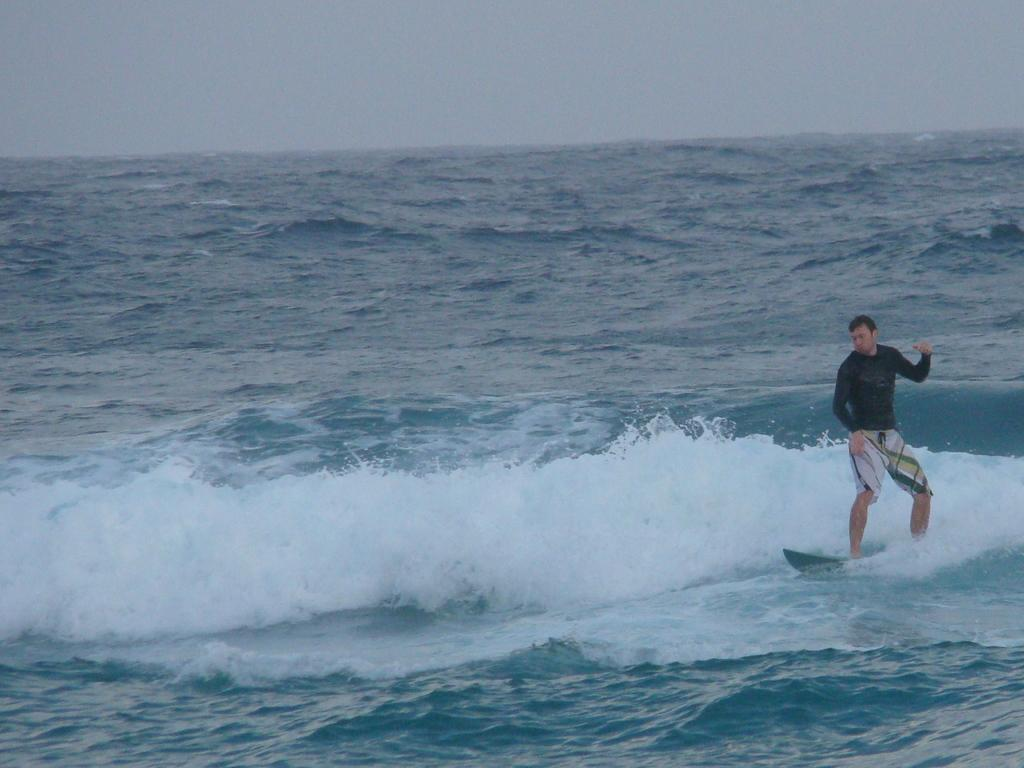What is the main subject of the image? There is a man in the image. What is the man doing in the image? The man is surfing on the surface of the sea. What can be seen in the background of the image? The sky is visible at the top of the image. What type of rhythm is the man following while surfing in the image? There is no indication of a specific rhythm in the image; the man is simply surfing on the sea. What type of dress is the man wearing while surfing in the image? The image does not show the man's clothing, so it cannot be determined what type of dress he is wearing. 